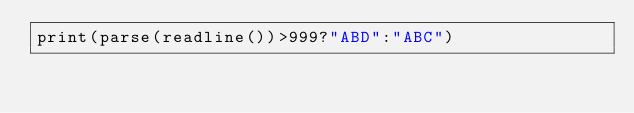Convert code to text. <code><loc_0><loc_0><loc_500><loc_500><_Julia_>print(parse(readline())>999?"ABD":"ABC")</code> 